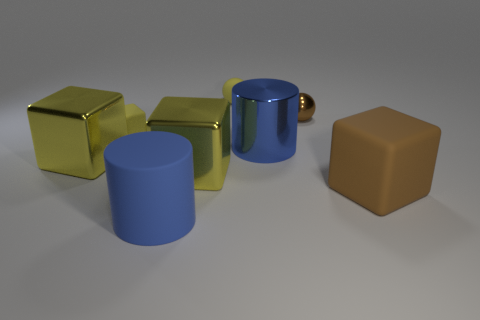There is a tiny sphere that is the same color as the tiny block; what is its material?
Ensure brevity in your answer.  Rubber. There is a large cube that is on the right side of the tiny rubber sphere; what is its color?
Your response must be concise. Brown. Is the size of the yellow cube behind the blue shiny thing the same as the metal cylinder?
Your answer should be compact. No. What size is the metallic object that is the same color as the large matte cube?
Your answer should be very brief. Small. Is there a yellow rubber cube that has the same size as the brown cube?
Give a very brief answer. No. Does the large cylinder that is behind the matte cylinder have the same color as the big object that is on the left side of the small yellow matte cube?
Offer a very short reply. No. Are there any matte things of the same color as the big metallic cylinder?
Keep it short and to the point. Yes. What number of other objects are the same shape as the small metal thing?
Offer a very short reply. 1. What shape is the small yellow rubber object behind the tiny yellow rubber block?
Your answer should be compact. Sphere. There is a large blue rubber object; is it the same shape as the blue object right of the large rubber cylinder?
Offer a terse response. Yes. 